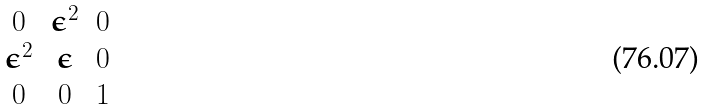Convert formula to latex. <formula><loc_0><loc_0><loc_500><loc_500>\begin{matrix} 0 & \epsilon ^ { 2 } & 0 \\ \epsilon ^ { 2 } & \epsilon & 0 \\ 0 & 0 & 1 \end{matrix}</formula> 